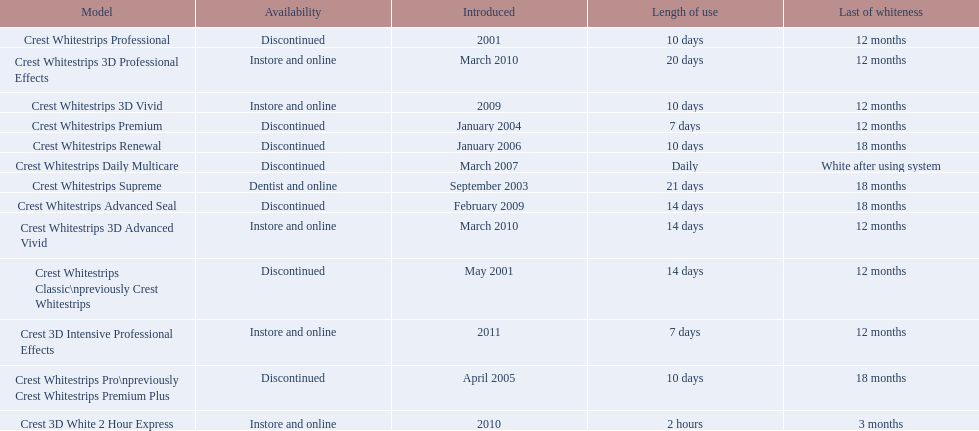Which model has the highest 'length of use' to 'last of whiteness' ratio? Crest Whitestrips Supreme. 